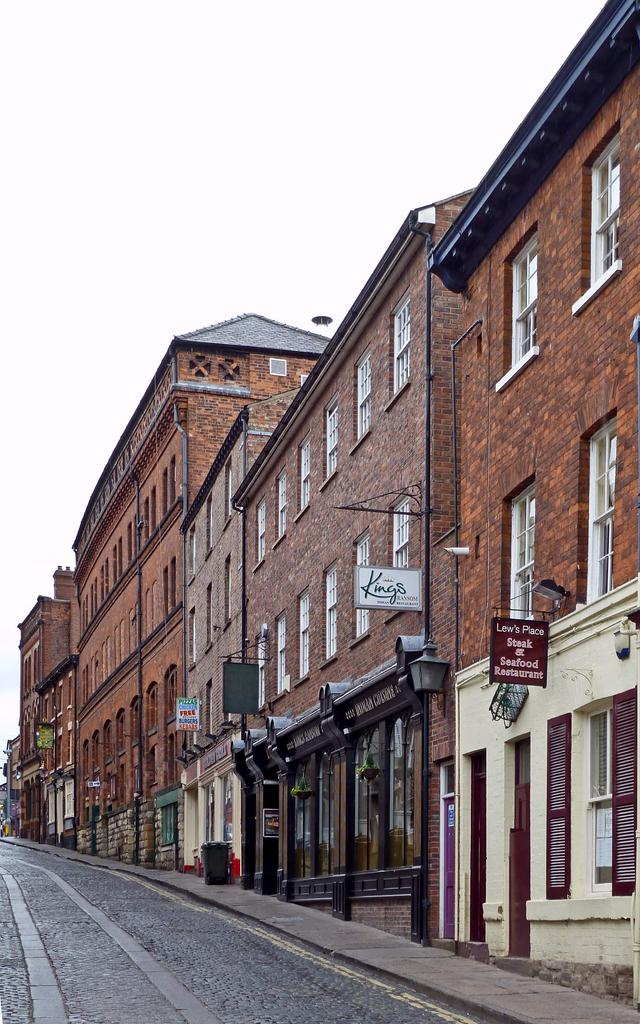What type of view is shown in the image? The image is an outside view. What can be seen at the bottom of the image? There is a road at the bottom of the image. What structures are located beside the road? There are many buildings beside the road. What is visible at the top of the image? The sky is visible at the top of the image. How many wrens can be seen flying over the buildings in the image? There are no wrens visible in the image; it is an outside view with a road, buildings, and sky. What type of balls are being used by the people in the image? There are no people or balls present in the image; it is a view of a road, buildings, and sky. 